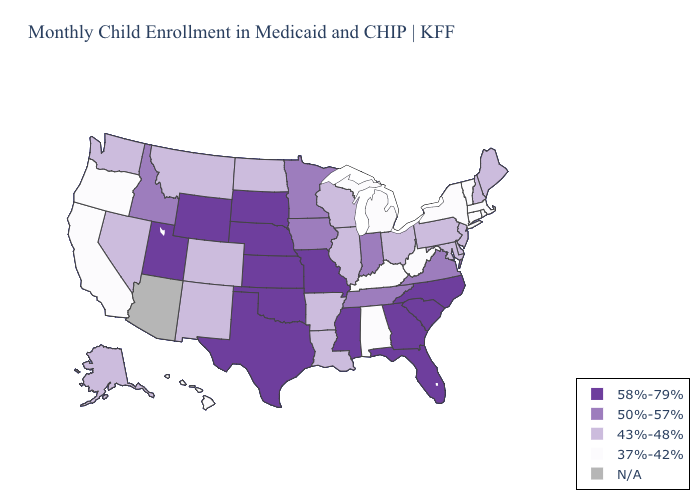What is the value of Michigan?
Short answer required. 37%-42%. Name the states that have a value in the range 37%-42%?
Keep it brief. Alabama, California, Connecticut, Hawaii, Kentucky, Massachusetts, Michigan, New York, Oregon, Rhode Island, Vermont, West Virginia. Name the states that have a value in the range 50%-57%?
Concise answer only. Idaho, Indiana, Iowa, Minnesota, Tennessee, Virginia. What is the highest value in the South ?
Short answer required. 58%-79%. What is the value of Louisiana?
Keep it brief. 43%-48%. What is the value of Colorado?
Give a very brief answer. 43%-48%. What is the highest value in states that border Maine?
Keep it brief. 43%-48%. What is the value of Ohio?
Answer briefly. 43%-48%. Among the states that border Arizona , does New Mexico have the highest value?
Concise answer only. No. What is the value of Indiana?
Keep it brief. 50%-57%. Among the states that border Nevada , does Idaho have the lowest value?
Short answer required. No. What is the lowest value in the Northeast?
Quick response, please. 37%-42%. What is the value of Florida?
Write a very short answer. 58%-79%. What is the value of Iowa?
Short answer required. 50%-57%. 